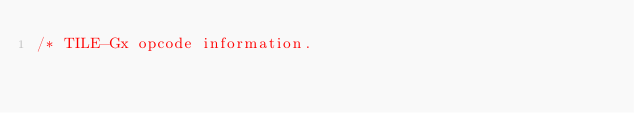Convert code to text. <code><loc_0><loc_0><loc_500><loc_500><_C_>/* TILE-Gx opcode information.
</code> 